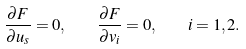<formula> <loc_0><loc_0><loc_500><loc_500>\frac { \partial F } { \partial u _ { s } } = 0 , \quad \frac { \partial F } { \partial v _ { i } } = 0 , \quad i = 1 , 2 .</formula> 